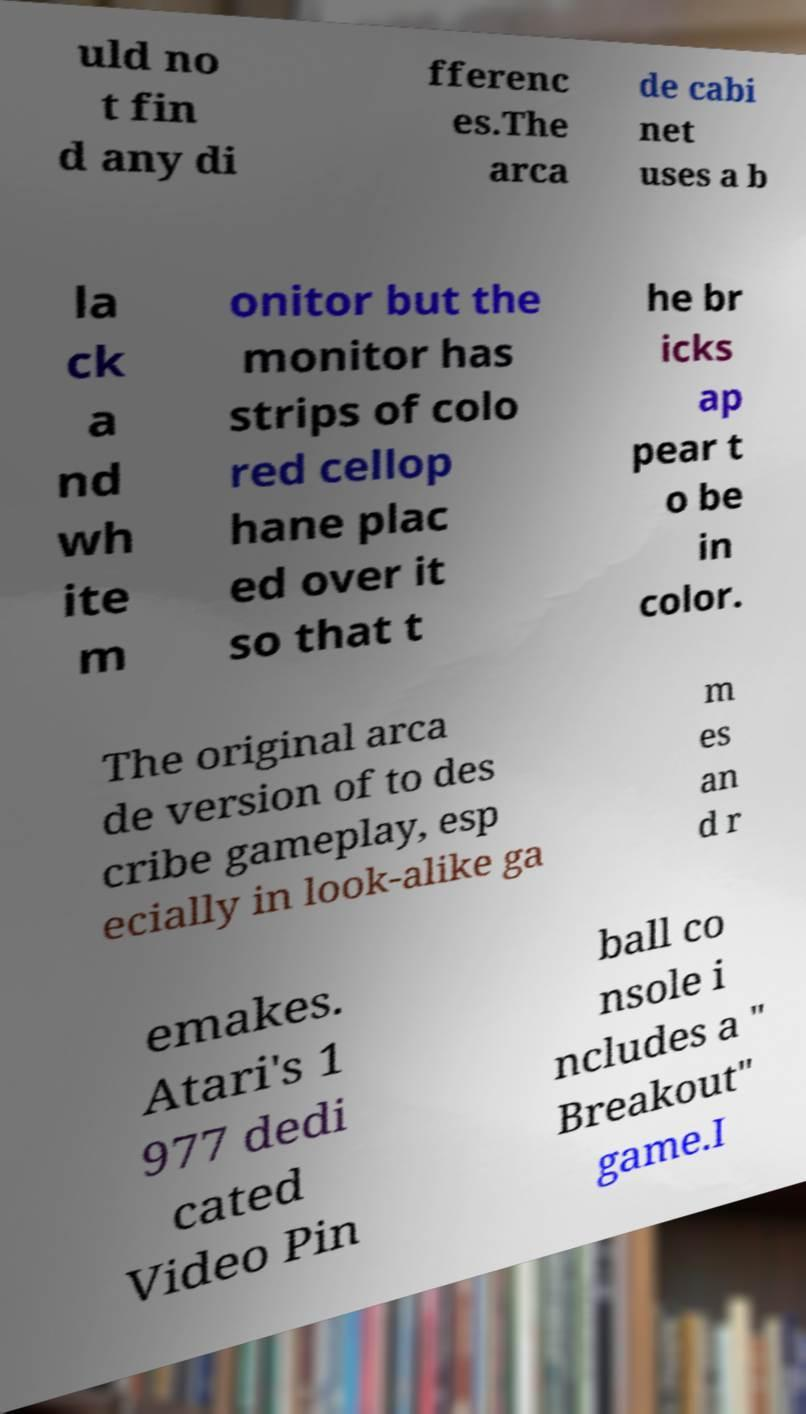What messages or text are displayed in this image? I need them in a readable, typed format. uld no t fin d any di fferenc es.The arca de cabi net uses a b la ck a nd wh ite m onitor but the monitor has strips of colo red cellop hane plac ed over it so that t he br icks ap pear t o be in color. The original arca de version of to des cribe gameplay, esp ecially in look-alike ga m es an d r emakes. Atari's 1 977 dedi cated Video Pin ball co nsole i ncludes a " Breakout" game.I 